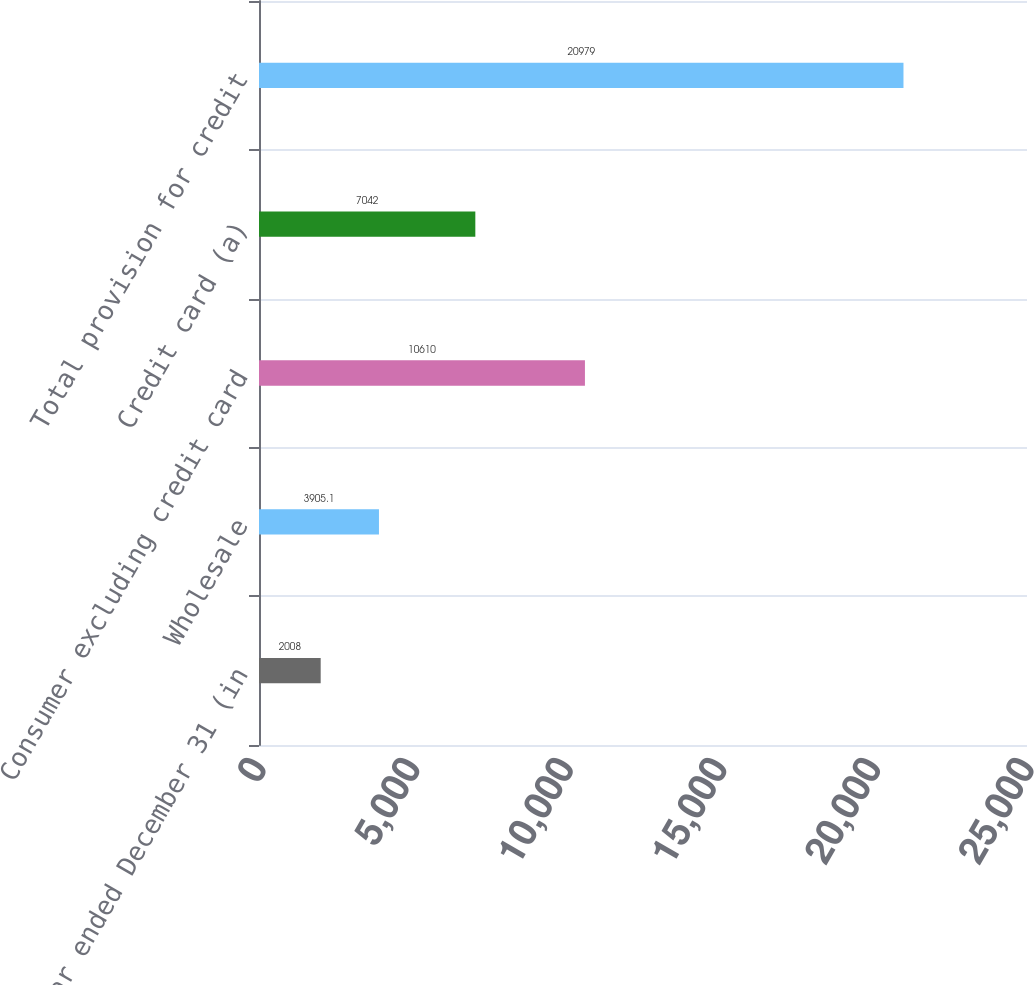<chart> <loc_0><loc_0><loc_500><loc_500><bar_chart><fcel>Year ended December 31 (in<fcel>Wholesale<fcel>Consumer excluding credit card<fcel>Credit card (a)<fcel>Total provision for credit<nl><fcel>2008<fcel>3905.1<fcel>10610<fcel>7042<fcel>20979<nl></chart> 